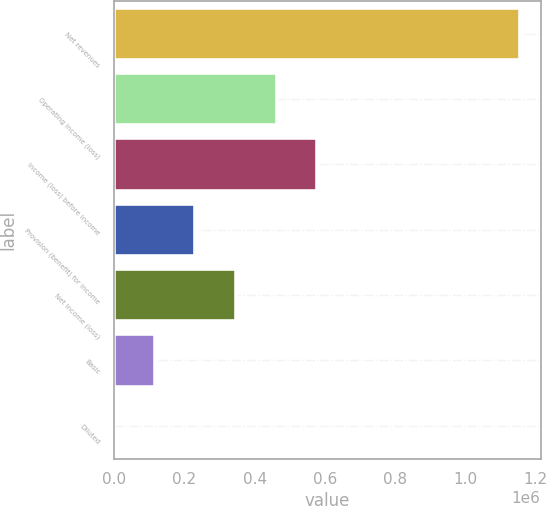<chart> <loc_0><loc_0><loc_500><loc_500><bar_chart><fcel>Net revenues<fcel>Operating income (loss)<fcel>Income (loss) before income<fcel>Provision (benefit) for income<fcel>Net income (loss)<fcel>Basic<fcel>Diluted<nl><fcel>1.15598e+06<fcel>462391<fcel>577989<fcel>231196<fcel>346793<fcel>115598<fcel>0.36<nl></chart> 